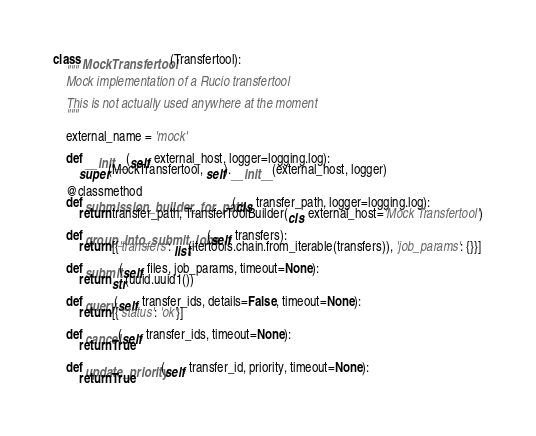Convert code to text. <code><loc_0><loc_0><loc_500><loc_500><_Python_>

class MockTransfertool(Transfertool):
    """
    Mock implementation of a Rucio transfertool

    This is not actually used anywhere at the moment
    """

    external_name = 'mock'

    def __init__(self, external_host, logger=logging.log):
        super(MockTransfertool, self).__init__(external_host, logger)

    @classmethod
    def submission_builder_for_path(cls, transfer_path, logger=logging.log):
        return transfer_path, TransferToolBuilder(cls, external_host='Mock Transfertool')

    def group_into_submit_jobs(self, transfers):
        return [{'transfers': list(itertools.chain.from_iterable(transfers)), 'job_params': {}}]

    def submit(self, files, job_params, timeout=None):
        return str(uuid.uuid1())

    def query(self, transfer_ids, details=False, timeout=None):
        return [{'status': 'ok'}]

    def cancel(self, transfer_ids, timeout=None):
        return True

    def update_priority(self, transfer_id, priority, timeout=None):
        return True
</code> 